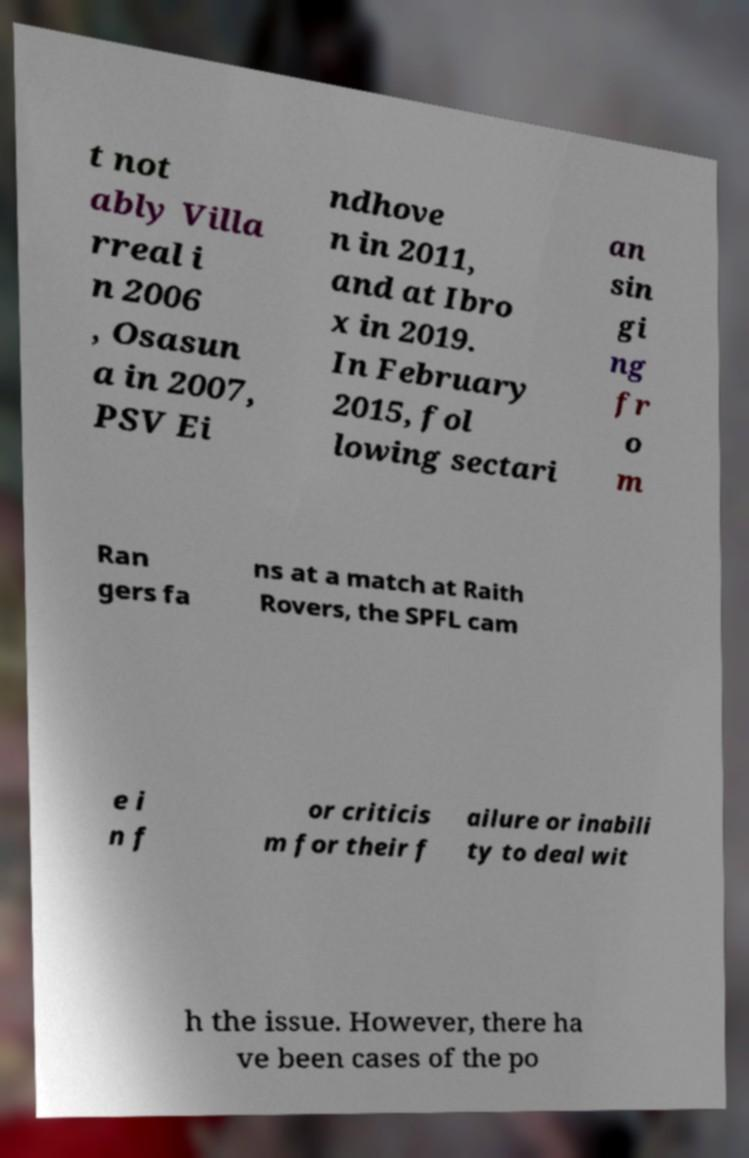For documentation purposes, I need the text within this image transcribed. Could you provide that? t not ably Villa rreal i n 2006 , Osasun a in 2007, PSV Ei ndhove n in 2011, and at Ibro x in 2019. In February 2015, fol lowing sectari an sin gi ng fr o m Ran gers fa ns at a match at Raith Rovers, the SPFL cam e i n f or criticis m for their f ailure or inabili ty to deal wit h the issue. However, there ha ve been cases of the po 